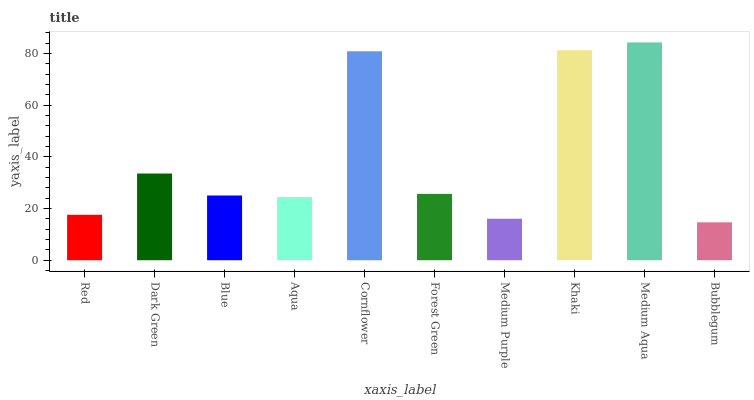Is Bubblegum the minimum?
Answer yes or no. Yes. Is Medium Aqua the maximum?
Answer yes or no. Yes. Is Dark Green the minimum?
Answer yes or no. No. Is Dark Green the maximum?
Answer yes or no. No. Is Dark Green greater than Red?
Answer yes or no. Yes. Is Red less than Dark Green?
Answer yes or no. Yes. Is Red greater than Dark Green?
Answer yes or no. No. Is Dark Green less than Red?
Answer yes or no. No. Is Forest Green the high median?
Answer yes or no. Yes. Is Blue the low median?
Answer yes or no. Yes. Is Bubblegum the high median?
Answer yes or no. No. Is Medium Purple the low median?
Answer yes or no. No. 